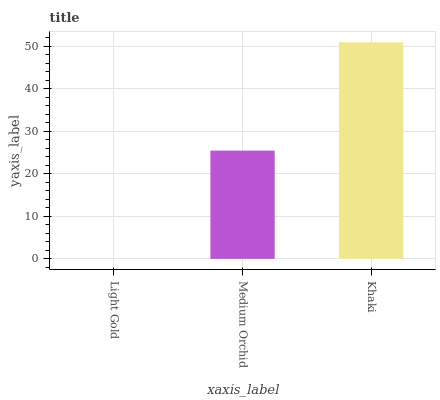Is Medium Orchid the minimum?
Answer yes or no. No. Is Medium Orchid the maximum?
Answer yes or no. No. Is Medium Orchid greater than Light Gold?
Answer yes or no. Yes. Is Light Gold less than Medium Orchid?
Answer yes or no. Yes. Is Light Gold greater than Medium Orchid?
Answer yes or no. No. Is Medium Orchid less than Light Gold?
Answer yes or no. No. Is Medium Orchid the high median?
Answer yes or no. Yes. Is Medium Orchid the low median?
Answer yes or no. Yes. Is Khaki the high median?
Answer yes or no. No. Is Light Gold the low median?
Answer yes or no. No. 